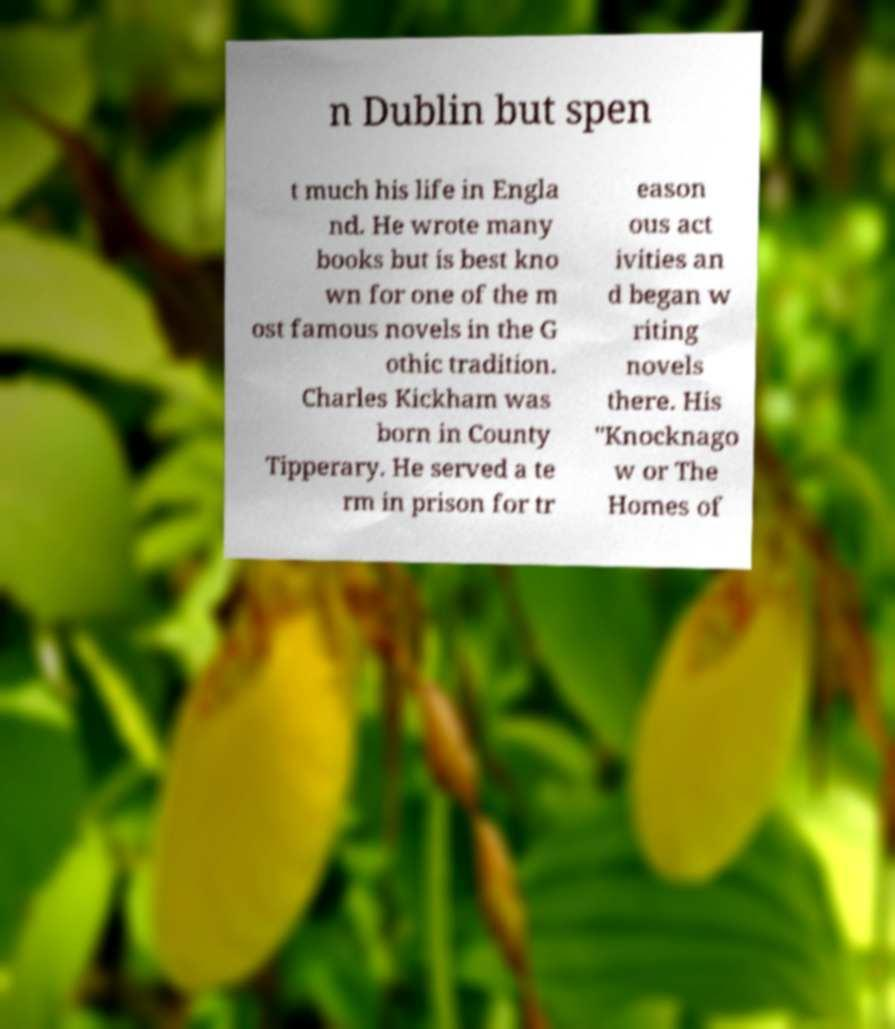Can you read and provide the text displayed in the image?This photo seems to have some interesting text. Can you extract and type it out for me? n Dublin but spen t much his life in Engla nd. He wrote many books but is best kno wn for one of the m ost famous novels in the G othic tradition. Charles Kickham was born in County Tipperary. He served a te rm in prison for tr eason ous act ivities an d began w riting novels there. His "Knocknago w or The Homes of 